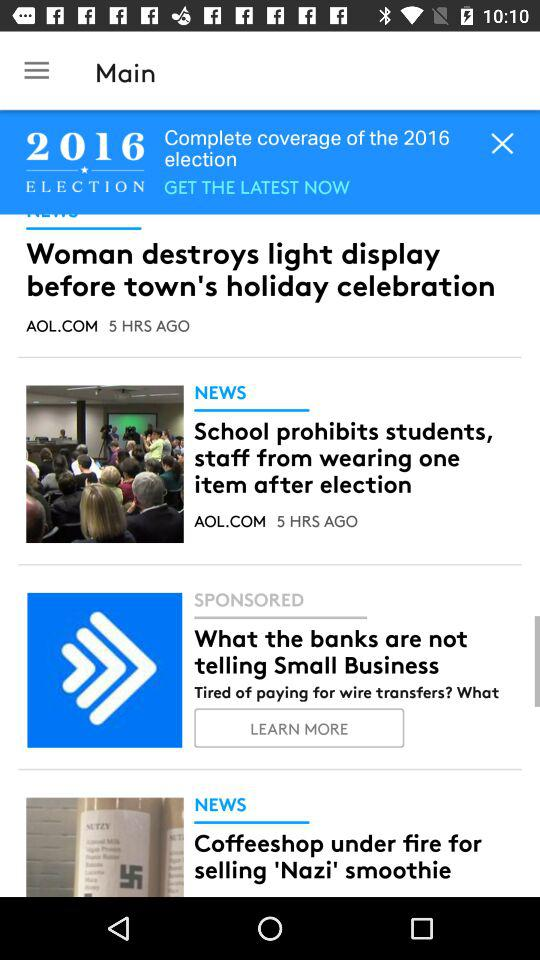How many more news items are there than sponsored items?
Answer the question using a single word or phrase. 2 